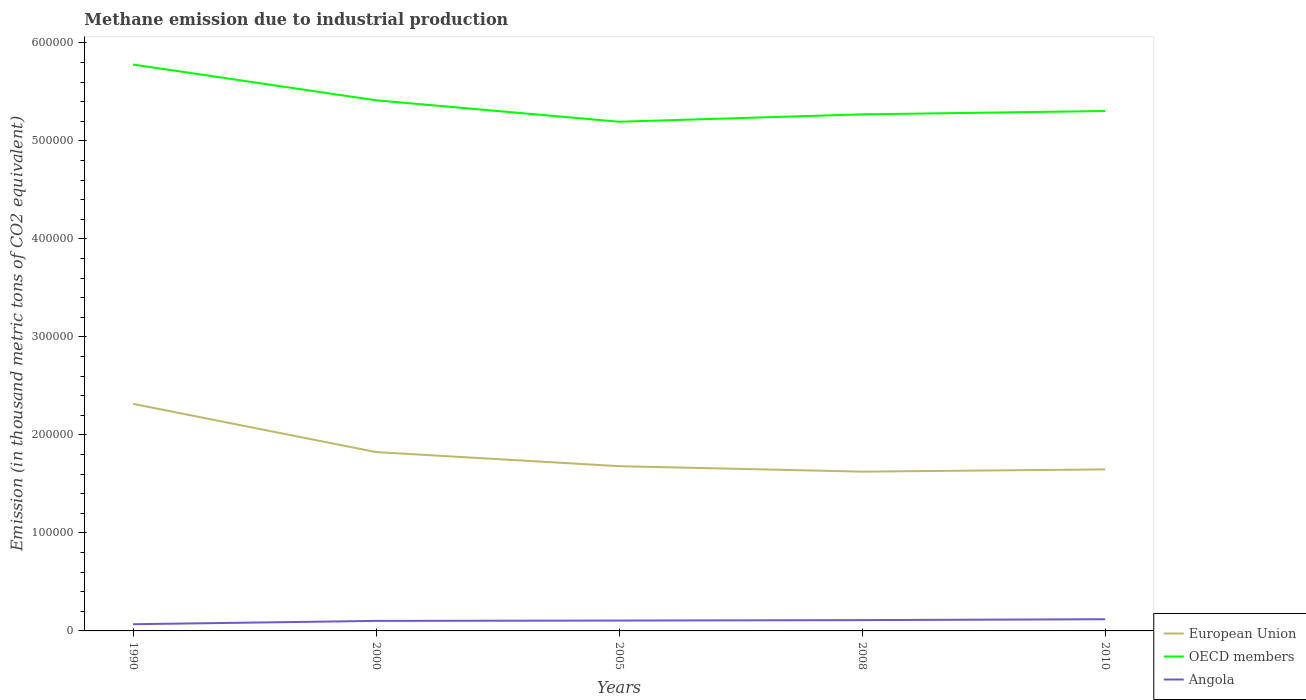Does the line corresponding to OECD members intersect with the line corresponding to European Union?
Give a very brief answer. No. Across all years, what is the maximum amount of methane emitted in European Union?
Keep it short and to the point. 1.63e+05. What is the total amount of methane emitted in OECD members in the graph?
Give a very brief answer. 2.19e+04. What is the difference between the highest and the second highest amount of methane emitted in OECD members?
Ensure brevity in your answer.  5.83e+04. Is the amount of methane emitted in European Union strictly greater than the amount of methane emitted in Angola over the years?
Offer a very short reply. No. How many lines are there?
Provide a short and direct response. 3. What is the difference between two consecutive major ticks on the Y-axis?
Offer a terse response. 1.00e+05. Does the graph contain any zero values?
Provide a short and direct response. No. Does the graph contain grids?
Your answer should be very brief. No. Where does the legend appear in the graph?
Keep it short and to the point. Bottom right. What is the title of the graph?
Your answer should be compact. Methane emission due to industrial production. What is the label or title of the Y-axis?
Ensure brevity in your answer.  Emission (in thousand metric tons of CO2 equivalent). What is the Emission (in thousand metric tons of CO2 equivalent) in European Union in 1990?
Ensure brevity in your answer.  2.32e+05. What is the Emission (in thousand metric tons of CO2 equivalent) in OECD members in 1990?
Give a very brief answer. 5.78e+05. What is the Emission (in thousand metric tons of CO2 equivalent) of Angola in 1990?
Ensure brevity in your answer.  6841.7. What is the Emission (in thousand metric tons of CO2 equivalent) in European Union in 2000?
Offer a very short reply. 1.82e+05. What is the Emission (in thousand metric tons of CO2 equivalent) of OECD members in 2000?
Provide a short and direct response. 5.41e+05. What is the Emission (in thousand metric tons of CO2 equivalent) in Angola in 2000?
Keep it short and to the point. 1.02e+04. What is the Emission (in thousand metric tons of CO2 equivalent) in European Union in 2005?
Offer a terse response. 1.68e+05. What is the Emission (in thousand metric tons of CO2 equivalent) of OECD members in 2005?
Keep it short and to the point. 5.19e+05. What is the Emission (in thousand metric tons of CO2 equivalent) of Angola in 2005?
Provide a succinct answer. 1.06e+04. What is the Emission (in thousand metric tons of CO2 equivalent) in European Union in 2008?
Provide a succinct answer. 1.63e+05. What is the Emission (in thousand metric tons of CO2 equivalent) in OECD members in 2008?
Keep it short and to the point. 5.27e+05. What is the Emission (in thousand metric tons of CO2 equivalent) of Angola in 2008?
Make the answer very short. 1.10e+04. What is the Emission (in thousand metric tons of CO2 equivalent) in European Union in 2010?
Keep it short and to the point. 1.65e+05. What is the Emission (in thousand metric tons of CO2 equivalent) of OECD members in 2010?
Keep it short and to the point. 5.30e+05. What is the Emission (in thousand metric tons of CO2 equivalent) in Angola in 2010?
Give a very brief answer. 1.19e+04. Across all years, what is the maximum Emission (in thousand metric tons of CO2 equivalent) in European Union?
Your answer should be very brief. 2.32e+05. Across all years, what is the maximum Emission (in thousand metric tons of CO2 equivalent) of OECD members?
Ensure brevity in your answer.  5.78e+05. Across all years, what is the maximum Emission (in thousand metric tons of CO2 equivalent) in Angola?
Ensure brevity in your answer.  1.19e+04. Across all years, what is the minimum Emission (in thousand metric tons of CO2 equivalent) in European Union?
Keep it short and to the point. 1.63e+05. Across all years, what is the minimum Emission (in thousand metric tons of CO2 equivalent) of OECD members?
Provide a short and direct response. 5.19e+05. Across all years, what is the minimum Emission (in thousand metric tons of CO2 equivalent) of Angola?
Your answer should be compact. 6841.7. What is the total Emission (in thousand metric tons of CO2 equivalent) of European Union in the graph?
Offer a terse response. 9.09e+05. What is the total Emission (in thousand metric tons of CO2 equivalent) in OECD members in the graph?
Keep it short and to the point. 2.70e+06. What is the total Emission (in thousand metric tons of CO2 equivalent) in Angola in the graph?
Your response must be concise. 5.06e+04. What is the difference between the Emission (in thousand metric tons of CO2 equivalent) in European Union in 1990 and that in 2000?
Make the answer very short. 4.92e+04. What is the difference between the Emission (in thousand metric tons of CO2 equivalent) of OECD members in 1990 and that in 2000?
Offer a terse response. 3.65e+04. What is the difference between the Emission (in thousand metric tons of CO2 equivalent) of Angola in 1990 and that in 2000?
Your answer should be very brief. -3399.1. What is the difference between the Emission (in thousand metric tons of CO2 equivalent) of European Union in 1990 and that in 2005?
Your response must be concise. 6.36e+04. What is the difference between the Emission (in thousand metric tons of CO2 equivalent) of OECD members in 1990 and that in 2005?
Keep it short and to the point. 5.83e+04. What is the difference between the Emission (in thousand metric tons of CO2 equivalent) of Angola in 1990 and that in 2005?
Provide a succinct answer. -3720.7. What is the difference between the Emission (in thousand metric tons of CO2 equivalent) of European Union in 1990 and that in 2008?
Keep it short and to the point. 6.91e+04. What is the difference between the Emission (in thousand metric tons of CO2 equivalent) of OECD members in 1990 and that in 2008?
Provide a succinct answer. 5.08e+04. What is the difference between the Emission (in thousand metric tons of CO2 equivalent) in Angola in 1990 and that in 2008?
Ensure brevity in your answer.  -4190.2. What is the difference between the Emission (in thousand metric tons of CO2 equivalent) of European Union in 1990 and that in 2010?
Offer a very short reply. 6.69e+04. What is the difference between the Emission (in thousand metric tons of CO2 equivalent) in OECD members in 1990 and that in 2010?
Make the answer very short. 4.74e+04. What is the difference between the Emission (in thousand metric tons of CO2 equivalent) in Angola in 1990 and that in 2010?
Make the answer very short. -5084.3. What is the difference between the Emission (in thousand metric tons of CO2 equivalent) of European Union in 2000 and that in 2005?
Offer a very short reply. 1.44e+04. What is the difference between the Emission (in thousand metric tons of CO2 equivalent) in OECD members in 2000 and that in 2005?
Provide a short and direct response. 2.19e+04. What is the difference between the Emission (in thousand metric tons of CO2 equivalent) of Angola in 2000 and that in 2005?
Make the answer very short. -321.6. What is the difference between the Emission (in thousand metric tons of CO2 equivalent) in European Union in 2000 and that in 2008?
Keep it short and to the point. 1.99e+04. What is the difference between the Emission (in thousand metric tons of CO2 equivalent) in OECD members in 2000 and that in 2008?
Offer a terse response. 1.43e+04. What is the difference between the Emission (in thousand metric tons of CO2 equivalent) of Angola in 2000 and that in 2008?
Your answer should be compact. -791.1. What is the difference between the Emission (in thousand metric tons of CO2 equivalent) of European Union in 2000 and that in 2010?
Make the answer very short. 1.77e+04. What is the difference between the Emission (in thousand metric tons of CO2 equivalent) in OECD members in 2000 and that in 2010?
Your answer should be compact. 1.09e+04. What is the difference between the Emission (in thousand metric tons of CO2 equivalent) of Angola in 2000 and that in 2010?
Make the answer very short. -1685.2. What is the difference between the Emission (in thousand metric tons of CO2 equivalent) of European Union in 2005 and that in 2008?
Ensure brevity in your answer.  5562. What is the difference between the Emission (in thousand metric tons of CO2 equivalent) in OECD members in 2005 and that in 2008?
Provide a short and direct response. -7540.4. What is the difference between the Emission (in thousand metric tons of CO2 equivalent) of Angola in 2005 and that in 2008?
Offer a very short reply. -469.5. What is the difference between the Emission (in thousand metric tons of CO2 equivalent) of European Union in 2005 and that in 2010?
Your answer should be compact. 3298.2. What is the difference between the Emission (in thousand metric tons of CO2 equivalent) in OECD members in 2005 and that in 2010?
Your answer should be compact. -1.09e+04. What is the difference between the Emission (in thousand metric tons of CO2 equivalent) in Angola in 2005 and that in 2010?
Ensure brevity in your answer.  -1363.6. What is the difference between the Emission (in thousand metric tons of CO2 equivalent) in European Union in 2008 and that in 2010?
Give a very brief answer. -2263.8. What is the difference between the Emission (in thousand metric tons of CO2 equivalent) of OECD members in 2008 and that in 2010?
Your response must be concise. -3406. What is the difference between the Emission (in thousand metric tons of CO2 equivalent) in Angola in 2008 and that in 2010?
Give a very brief answer. -894.1. What is the difference between the Emission (in thousand metric tons of CO2 equivalent) of European Union in 1990 and the Emission (in thousand metric tons of CO2 equivalent) of OECD members in 2000?
Provide a succinct answer. -3.10e+05. What is the difference between the Emission (in thousand metric tons of CO2 equivalent) in European Union in 1990 and the Emission (in thousand metric tons of CO2 equivalent) in Angola in 2000?
Your response must be concise. 2.21e+05. What is the difference between the Emission (in thousand metric tons of CO2 equivalent) in OECD members in 1990 and the Emission (in thousand metric tons of CO2 equivalent) in Angola in 2000?
Provide a succinct answer. 5.68e+05. What is the difference between the Emission (in thousand metric tons of CO2 equivalent) in European Union in 1990 and the Emission (in thousand metric tons of CO2 equivalent) in OECD members in 2005?
Offer a terse response. -2.88e+05. What is the difference between the Emission (in thousand metric tons of CO2 equivalent) in European Union in 1990 and the Emission (in thousand metric tons of CO2 equivalent) in Angola in 2005?
Keep it short and to the point. 2.21e+05. What is the difference between the Emission (in thousand metric tons of CO2 equivalent) of OECD members in 1990 and the Emission (in thousand metric tons of CO2 equivalent) of Angola in 2005?
Your answer should be compact. 5.67e+05. What is the difference between the Emission (in thousand metric tons of CO2 equivalent) of European Union in 1990 and the Emission (in thousand metric tons of CO2 equivalent) of OECD members in 2008?
Give a very brief answer. -2.95e+05. What is the difference between the Emission (in thousand metric tons of CO2 equivalent) of European Union in 1990 and the Emission (in thousand metric tons of CO2 equivalent) of Angola in 2008?
Your response must be concise. 2.21e+05. What is the difference between the Emission (in thousand metric tons of CO2 equivalent) of OECD members in 1990 and the Emission (in thousand metric tons of CO2 equivalent) of Angola in 2008?
Ensure brevity in your answer.  5.67e+05. What is the difference between the Emission (in thousand metric tons of CO2 equivalent) in European Union in 1990 and the Emission (in thousand metric tons of CO2 equivalent) in OECD members in 2010?
Keep it short and to the point. -2.99e+05. What is the difference between the Emission (in thousand metric tons of CO2 equivalent) in European Union in 1990 and the Emission (in thousand metric tons of CO2 equivalent) in Angola in 2010?
Your response must be concise. 2.20e+05. What is the difference between the Emission (in thousand metric tons of CO2 equivalent) of OECD members in 1990 and the Emission (in thousand metric tons of CO2 equivalent) of Angola in 2010?
Offer a terse response. 5.66e+05. What is the difference between the Emission (in thousand metric tons of CO2 equivalent) of European Union in 2000 and the Emission (in thousand metric tons of CO2 equivalent) of OECD members in 2005?
Make the answer very short. -3.37e+05. What is the difference between the Emission (in thousand metric tons of CO2 equivalent) in European Union in 2000 and the Emission (in thousand metric tons of CO2 equivalent) in Angola in 2005?
Provide a short and direct response. 1.72e+05. What is the difference between the Emission (in thousand metric tons of CO2 equivalent) of OECD members in 2000 and the Emission (in thousand metric tons of CO2 equivalent) of Angola in 2005?
Your answer should be compact. 5.31e+05. What is the difference between the Emission (in thousand metric tons of CO2 equivalent) of European Union in 2000 and the Emission (in thousand metric tons of CO2 equivalent) of OECD members in 2008?
Offer a terse response. -3.45e+05. What is the difference between the Emission (in thousand metric tons of CO2 equivalent) in European Union in 2000 and the Emission (in thousand metric tons of CO2 equivalent) in Angola in 2008?
Make the answer very short. 1.71e+05. What is the difference between the Emission (in thousand metric tons of CO2 equivalent) of OECD members in 2000 and the Emission (in thousand metric tons of CO2 equivalent) of Angola in 2008?
Provide a succinct answer. 5.30e+05. What is the difference between the Emission (in thousand metric tons of CO2 equivalent) in European Union in 2000 and the Emission (in thousand metric tons of CO2 equivalent) in OECD members in 2010?
Provide a succinct answer. -3.48e+05. What is the difference between the Emission (in thousand metric tons of CO2 equivalent) of European Union in 2000 and the Emission (in thousand metric tons of CO2 equivalent) of Angola in 2010?
Provide a short and direct response. 1.71e+05. What is the difference between the Emission (in thousand metric tons of CO2 equivalent) of OECD members in 2000 and the Emission (in thousand metric tons of CO2 equivalent) of Angola in 2010?
Give a very brief answer. 5.29e+05. What is the difference between the Emission (in thousand metric tons of CO2 equivalent) in European Union in 2005 and the Emission (in thousand metric tons of CO2 equivalent) in OECD members in 2008?
Ensure brevity in your answer.  -3.59e+05. What is the difference between the Emission (in thousand metric tons of CO2 equivalent) in European Union in 2005 and the Emission (in thousand metric tons of CO2 equivalent) in Angola in 2008?
Give a very brief answer. 1.57e+05. What is the difference between the Emission (in thousand metric tons of CO2 equivalent) in OECD members in 2005 and the Emission (in thousand metric tons of CO2 equivalent) in Angola in 2008?
Ensure brevity in your answer.  5.08e+05. What is the difference between the Emission (in thousand metric tons of CO2 equivalent) of European Union in 2005 and the Emission (in thousand metric tons of CO2 equivalent) of OECD members in 2010?
Your answer should be very brief. -3.62e+05. What is the difference between the Emission (in thousand metric tons of CO2 equivalent) in European Union in 2005 and the Emission (in thousand metric tons of CO2 equivalent) in Angola in 2010?
Make the answer very short. 1.56e+05. What is the difference between the Emission (in thousand metric tons of CO2 equivalent) in OECD members in 2005 and the Emission (in thousand metric tons of CO2 equivalent) in Angola in 2010?
Provide a short and direct response. 5.08e+05. What is the difference between the Emission (in thousand metric tons of CO2 equivalent) of European Union in 2008 and the Emission (in thousand metric tons of CO2 equivalent) of OECD members in 2010?
Your answer should be very brief. -3.68e+05. What is the difference between the Emission (in thousand metric tons of CO2 equivalent) of European Union in 2008 and the Emission (in thousand metric tons of CO2 equivalent) of Angola in 2010?
Offer a very short reply. 1.51e+05. What is the difference between the Emission (in thousand metric tons of CO2 equivalent) of OECD members in 2008 and the Emission (in thousand metric tons of CO2 equivalent) of Angola in 2010?
Offer a terse response. 5.15e+05. What is the average Emission (in thousand metric tons of CO2 equivalent) of European Union per year?
Ensure brevity in your answer.  1.82e+05. What is the average Emission (in thousand metric tons of CO2 equivalent) of OECD members per year?
Ensure brevity in your answer.  5.39e+05. What is the average Emission (in thousand metric tons of CO2 equivalent) in Angola per year?
Ensure brevity in your answer.  1.01e+04. In the year 1990, what is the difference between the Emission (in thousand metric tons of CO2 equivalent) of European Union and Emission (in thousand metric tons of CO2 equivalent) of OECD members?
Your answer should be compact. -3.46e+05. In the year 1990, what is the difference between the Emission (in thousand metric tons of CO2 equivalent) in European Union and Emission (in thousand metric tons of CO2 equivalent) in Angola?
Give a very brief answer. 2.25e+05. In the year 1990, what is the difference between the Emission (in thousand metric tons of CO2 equivalent) in OECD members and Emission (in thousand metric tons of CO2 equivalent) in Angola?
Your answer should be compact. 5.71e+05. In the year 2000, what is the difference between the Emission (in thousand metric tons of CO2 equivalent) in European Union and Emission (in thousand metric tons of CO2 equivalent) in OECD members?
Provide a short and direct response. -3.59e+05. In the year 2000, what is the difference between the Emission (in thousand metric tons of CO2 equivalent) of European Union and Emission (in thousand metric tons of CO2 equivalent) of Angola?
Your answer should be very brief. 1.72e+05. In the year 2000, what is the difference between the Emission (in thousand metric tons of CO2 equivalent) in OECD members and Emission (in thousand metric tons of CO2 equivalent) in Angola?
Give a very brief answer. 5.31e+05. In the year 2005, what is the difference between the Emission (in thousand metric tons of CO2 equivalent) of European Union and Emission (in thousand metric tons of CO2 equivalent) of OECD members?
Provide a short and direct response. -3.51e+05. In the year 2005, what is the difference between the Emission (in thousand metric tons of CO2 equivalent) of European Union and Emission (in thousand metric tons of CO2 equivalent) of Angola?
Provide a short and direct response. 1.58e+05. In the year 2005, what is the difference between the Emission (in thousand metric tons of CO2 equivalent) in OECD members and Emission (in thousand metric tons of CO2 equivalent) in Angola?
Your response must be concise. 5.09e+05. In the year 2008, what is the difference between the Emission (in thousand metric tons of CO2 equivalent) in European Union and Emission (in thousand metric tons of CO2 equivalent) in OECD members?
Your response must be concise. -3.64e+05. In the year 2008, what is the difference between the Emission (in thousand metric tons of CO2 equivalent) of European Union and Emission (in thousand metric tons of CO2 equivalent) of Angola?
Ensure brevity in your answer.  1.51e+05. In the year 2008, what is the difference between the Emission (in thousand metric tons of CO2 equivalent) of OECD members and Emission (in thousand metric tons of CO2 equivalent) of Angola?
Ensure brevity in your answer.  5.16e+05. In the year 2010, what is the difference between the Emission (in thousand metric tons of CO2 equivalent) of European Union and Emission (in thousand metric tons of CO2 equivalent) of OECD members?
Offer a very short reply. -3.66e+05. In the year 2010, what is the difference between the Emission (in thousand metric tons of CO2 equivalent) in European Union and Emission (in thousand metric tons of CO2 equivalent) in Angola?
Provide a short and direct response. 1.53e+05. In the year 2010, what is the difference between the Emission (in thousand metric tons of CO2 equivalent) in OECD members and Emission (in thousand metric tons of CO2 equivalent) in Angola?
Ensure brevity in your answer.  5.18e+05. What is the ratio of the Emission (in thousand metric tons of CO2 equivalent) of European Union in 1990 to that in 2000?
Your answer should be very brief. 1.27. What is the ratio of the Emission (in thousand metric tons of CO2 equivalent) in OECD members in 1990 to that in 2000?
Give a very brief answer. 1.07. What is the ratio of the Emission (in thousand metric tons of CO2 equivalent) of Angola in 1990 to that in 2000?
Provide a short and direct response. 0.67. What is the ratio of the Emission (in thousand metric tons of CO2 equivalent) in European Union in 1990 to that in 2005?
Keep it short and to the point. 1.38. What is the ratio of the Emission (in thousand metric tons of CO2 equivalent) of OECD members in 1990 to that in 2005?
Keep it short and to the point. 1.11. What is the ratio of the Emission (in thousand metric tons of CO2 equivalent) in Angola in 1990 to that in 2005?
Your response must be concise. 0.65. What is the ratio of the Emission (in thousand metric tons of CO2 equivalent) of European Union in 1990 to that in 2008?
Ensure brevity in your answer.  1.43. What is the ratio of the Emission (in thousand metric tons of CO2 equivalent) in OECD members in 1990 to that in 2008?
Provide a short and direct response. 1.1. What is the ratio of the Emission (in thousand metric tons of CO2 equivalent) of Angola in 1990 to that in 2008?
Offer a very short reply. 0.62. What is the ratio of the Emission (in thousand metric tons of CO2 equivalent) of European Union in 1990 to that in 2010?
Offer a terse response. 1.41. What is the ratio of the Emission (in thousand metric tons of CO2 equivalent) of OECD members in 1990 to that in 2010?
Provide a succinct answer. 1.09. What is the ratio of the Emission (in thousand metric tons of CO2 equivalent) in Angola in 1990 to that in 2010?
Your response must be concise. 0.57. What is the ratio of the Emission (in thousand metric tons of CO2 equivalent) in European Union in 2000 to that in 2005?
Make the answer very short. 1.09. What is the ratio of the Emission (in thousand metric tons of CO2 equivalent) in OECD members in 2000 to that in 2005?
Ensure brevity in your answer.  1.04. What is the ratio of the Emission (in thousand metric tons of CO2 equivalent) in Angola in 2000 to that in 2005?
Offer a very short reply. 0.97. What is the ratio of the Emission (in thousand metric tons of CO2 equivalent) of European Union in 2000 to that in 2008?
Provide a short and direct response. 1.12. What is the ratio of the Emission (in thousand metric tons of CO2 equivalent) of OECD members in 2000 to that in 2008?
Your response must be concise. 1.03. What is the ratio of the Emission (in thousand metric tons of CO2 equivalent) of Angola in 2000 to that in 2008?
Your response must be concise. 0.93. What is the ratio of the Emission (in thousand metric tons of CO2 equivalent) in European Union in 2000 to that in 2010?
Your response must be concise. 1.11. What is the ratio of the Emission (in thousand metric tons of CO2 equivalent) in OECD members in 2000 to that in 2010?
Offer a terse response. 1.02. What is the ratio of the Emission (in thousand metric tons of CO2 equivalent) in Angola in 2000 to that in 2010?
Ensure brevity in your answer.  0.86. What is the ratio of the Emission (in thousand metric tons of CO2 equivalent) in European Union in 2005 to that in 2008?
Your response must be concise. 1.03. What is the ratio of the Emission (in thousand metric tons of CO2 equivalent) in OECD members in 2005 to that in 2008?
Offer a very short reply. 0.99. What is the ratio of the Emission (in thousand metric tons of CO2 equivalent) in Angola in 2005 to that in 2008?
Provide a short and direct response. 0.96. What is the ratio of the Emission (in thousand metric tons of CO2 equivalent) in OECD members in 2005 to that in 2010?
Your answer should be compact. 0.98. What is the ratio of the Emission (in thousand metric tons of CO2 equivalent) in Angola in 2005 to that in 2010?
Make the answer very short. 0.89. What is the ratio of the Emission (in thousand metric tons of CO2 equivalent) of European Union in 2008 to that in 2010?
Offer a terse response. 0.99. What is the ratio of the Emission (in thousand metric tons of CO2 equivalent) in Angola in 2008 to that in 2010?
Your answer should be compact. 0.93. What is the difference between the highest and the second highest Emission (in thousand metric tons of CO2 equivalent) of European Union?
Keep it short and to the point. 4.92e+04. What is the difference between the highest and the second highest Emission (in thousand metric tons of CO2 equivalent) of OECD members?
Keep it short and to the point. 3.65e+04. What is the difference between the highest and the second highest Emission (in thousand metric tons of CO2 equivalent) in Angola?
Your answer should be compact. 894.1. What is the difference between the highest and the lowest Emission (in thousand metric tons of CO2 equivalent) of European Union?
Offer a very short reply. 6.91e+04. What is the difference between the highest and the lowest Emission (in thousand metric tons of CO2 equivalent) of OECD members?
Your answer should be compact. 5.83e+04. What is the difference between the highest and the lowest Emission (in thousand metric tons of CO2 equivalent) in Angola?
Give a very brief answer. 5084.3. 